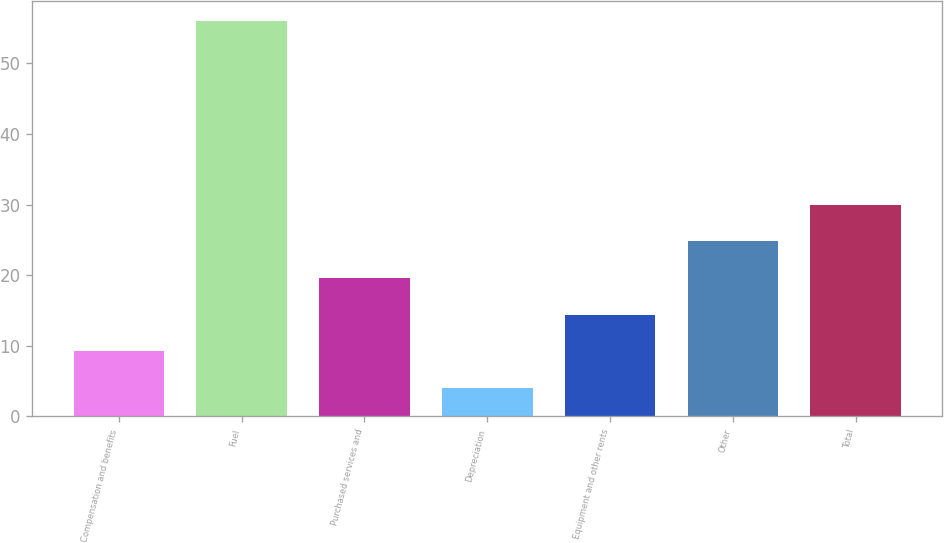Convert chart to OTSL. <chart><loc_0><loc_0><loc_500><loc_500><bar_chart><fcel>Compensation and benefits<fcel>Fuel<fcel>Purchased services and<fcel>Depreciation<fcel>Equipment and other rents<fcel>Other<fcel>Total<nl><fcel>9.2<fcel>56<fcel>19.6<fcel>4<fcel>14.4<fcel>24.8<fcel>30<nl></chart> 